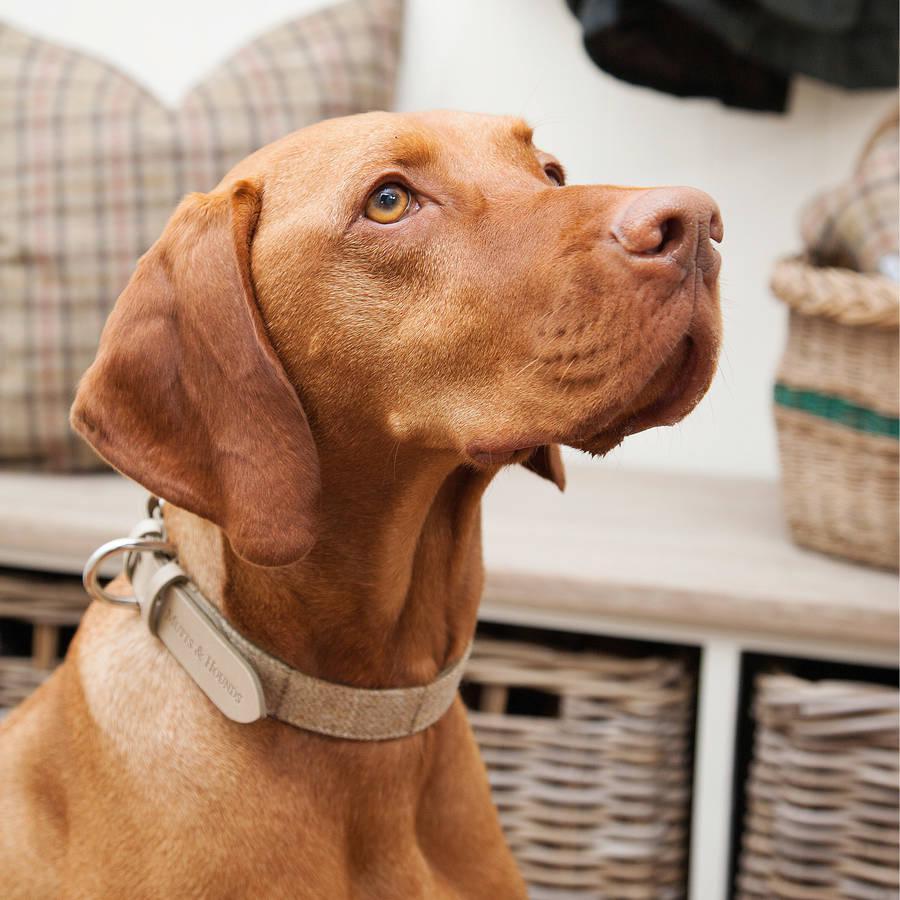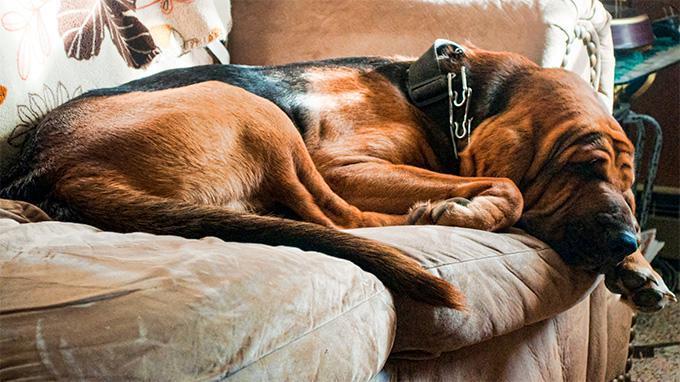The first image is the image on the left, the second image is the image on the right. Considering the images on both sides, is "The dog in the right image is sleeping." valid? Answer yes or no. Yes. The first image is the image on the left, the second image is the image on the right. Examine the images to the left and right. Is the description "Each image contains a single dog, and the right image shows a sleeping hound with its head to the right." accurate? Answer yes or no. Yes. 